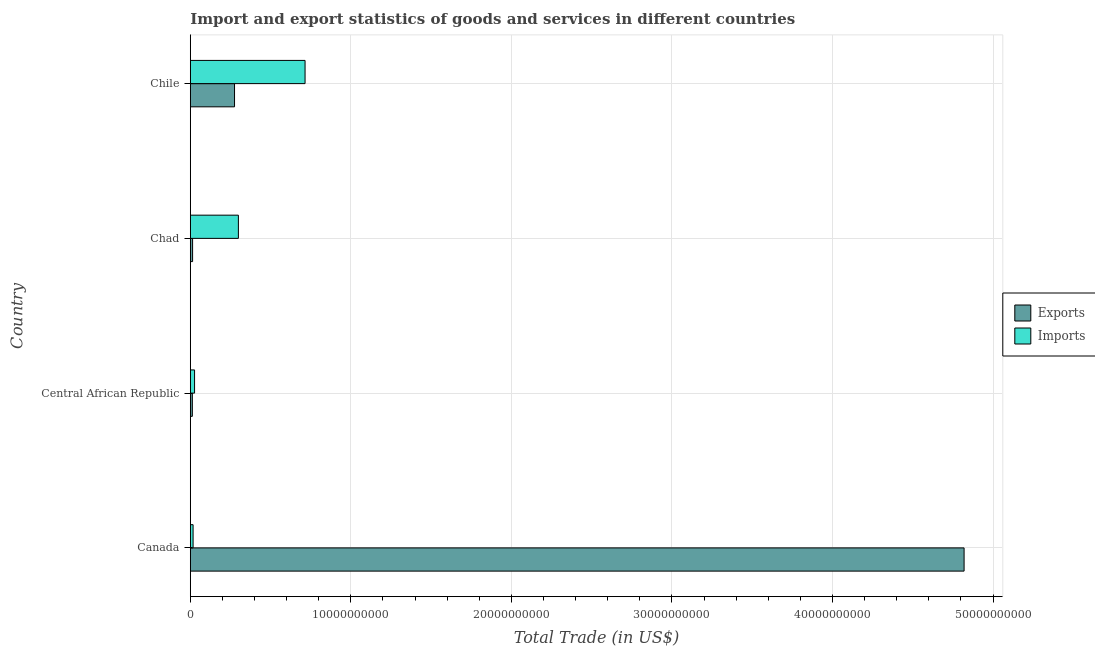How many different coloured bars are there?
Keep it short and to the point. 2. How many groups of bars are there?
Your answer should be compact. 4. In how many cases, is the number of bars for a given country not equal to the number of legend labels?
Your answer should be very brief. 0. What is the imports of goods and services in Chad?
Keep it short and to the point. 3.00e+09. Across all countries, what is the maximum imports of goods and services?
Offer a very short reply. 7.15e+09. Across all countries, what is the minimum imports of goods and services?
Make the answer very short. 1.74e+08. In which country was the imports of goods and services maximum?
Keep it short and to the point. Chile. In which country was the imports of goods and services minimum?
Offer a very short reply. Canada. What is the total export of goods and services in the graph?
Make the answer very short. 5.12e+1. What is the difference between the export of goods and services in Canada and that in Chile?
Provide a succinct answer. 4.54e+1. What is the difference between the export of goods and services in Canada and the imports of goods and services in Chile?
Give a very brief answer. 4.10e+1. What is the average imports of goods and services per country?
Provide a succinct answer. 2.65e+09. What is the difference between the imports of goods and services and export of goods and services in Canada?
Your response must be concise. -4.80e+1. In how many countries, is the imports of goods and services greater than 42000000000 US$?
Provide a short and direct response. 0. What is the ratio of the imports of goods and services in Canada to that in Chad?
Offer a very short reply. 0.06. Is the export of goods and services in Canada less than that in Chad?
Keep it short and to the point. No. Is the difference between the export of goods and services in Canada and Chile greater than the difference between the imports of goods and services in Canada and Chile?
Your response must be concise. Yes. What is the difference between the highest and the second highest export of goods and services?
Keep it short and to the point. 4.54e+1. What is the difference between the highest and the lowest imports of goods and services?
Offer a very short reply. 6.97e+09. Is the sum of the export of goods and services in Central African Republic and Chad greater than the maximum imports of goods and services across all countries?
Your answer should be compact. No. What does the 1st bar from the top in Canada represents?
Ensure brevity in your answer.  Imports. What does the 2nd bar from the bottom in Canada represents?
Offer a terse response. Imports. How many bars are there?
Your response must be concise. 8. How many legend labels are there?
Offer a very short reply. 2. How are the legend labels stacked?
Your answer should be compact. Vertical. What is the title of the graph?
Your answer should be very brief. Import and export statistics of goods and services in different countries. What is the label or title of the X-axis?
Make the answer very short. Total Trade (in US$). What is the Total Trade (in US$) of Exports in Canada?
Keep it short and to the point. 4.82e+1. What is the Total Trade (in US$) in Imports in Canada?
Make the answer very short. 1.74e+08. What is the Total Trade (in US$) in Exports in Central African Republic?
Keep it short and to the point. 1.28e+08. What is the Total Trade (in US$) in Imports in Central African Republic?
Ensure brevity in your answer.  2.65e+08. What is the Total Trade (in US$) of Exports in Chad?
Your answer should be compact. 1.44e+08. What is the Total Trade (in US$) of Imports in Chad?
Provide a succinct answer. 3.00e+09. What is the Total Trade (in US$) in Exports in Chile?
Provide a short and direct response. 2.75e+09. What is the Total Trade (in US$) in Imports in Chile?
Offer a terse response. 7.15e+09. Across all countries, what is the maximum Total Trade (in US$) in Exports?
Your response must be concise. 4.82e+1. Across all countries, what is the maximum Total Trade (in US$) of Imports?
Give a very brief answer. 7.15e+09. Across all countries, what is the minimum Total Trade (in US$) in Exports?
Provide a succinct answer. 1.28e+08. Across all countries, what is the minimum Total Trade (in US$) of Imports?
Offer a terse response. 1.74e+08. What is the total Total Trade (in US$) of Exports in the graph?
Make the answer very short. 5.12e+1. What is the total Total Trade (in US$) of Imports in the graph?
Provide a short and direct response. 1.06e+1. What is the difference between the Total Trade (in US$) in Exports in Canada and that in Central African Republic?
Give a very brief answer. 4.81e+1. What is the difference between the Total Trade (in US$) in Imports in Canada and that in Central African Republic?
Your answer should be compact. -9.13e+07. What is the difference between the Total Trade (in US$) in Exports in Canada and that in Chad?
Offer a very short reply. 4.81e+1. What is the difference between the Total Trade (in US$) in Imports in Canada and that in Chad?
Your answer should be very brief. -2.82e+09. What is the difference between the Total Trade (in US$) in Exports in Canada and that in Chile?
Provide a short and direct response. 4.54e+1. What is the difference between the Total Trade (in US$) of Imports in Canada and that in Chile?
Give a very brief answer. -6.97e+09. What is the difference between the Total Trade (in US$) of Exports in Central African Republic and that in Chad?
Offer a very short reply. -1.58e+07. What is the difference between the Total Trade (in US$) of Imports in Central African Republic and that in Chad?
Offer a very short reply. -2.73e+09. What is the difference between the Total Trade (in US$) in Exports in Central African Republic and that in Chile?
Your answer should be compact. -2.63e+09. What is the difference between the Total Trade (in US$) of Imports in Central African Republic and that in Chile?
Offer a terse response. -6.88e+09. What is the difference between the Total Trade (in US$) of Exports in Chad and that in Chile?
Keep it short and to the point. -2.61e+09. What is the difference between the Total Trade (in US$) in Imports in Chad and that in Chile?
Offer a terse response. -4.15e+09. What is the difference between the Total Trade (in US$) in Exports in Canada and the Total Trade (in US$) in Imports in Central African Republic?
Provide a succinct answer. 4.79e+1. What is the difference between the Total Trade (in US$) of Exports in Canada and the Total Trade (in US$) of Imports in Chad?
Ensure brevity in your answer.  4.52e+1. What is the difference between the Total Trade (in US$) of Exports in Canada and the Total Trade (in US$) of Imports in Chile?
Provide a short and direct response. 4.10e+1. What is the difference between the Total Trade (in US$) of Exports in Central African Republic and the Total Trade (in US$) of Imports in Chad?
Keep it short and to the point. -2.87e+09. What is the difference between the Total Trade (in US$) in Exports in Central African Republic and the Total Trade (in US$) in Imports in Chile?
Your response must be concise. -7.02e+09. What is the difference between the Total Trade (in US$) in Exports in Chad and the Total Trade (in US$) in Imports in Chile?
Ensure brevity in your answer.  -7.00e+09. What is the average Total Trade (in US$) of Exports per country?
Offer a terse response. 1.28e+1. What is the average Total Trade (in US$) in Imports per country?
Your answer should be compact. 2.65e+09. What is the difference between the Total Trade (in US$) in Exports and Total Trade (in US$) in Imports in Canada?
Provide a short and direct response. 4.80e+1. What is the difference between the Total Trade (in US$) of Exports and Total Trade (in US$) of Imports in Central African Republic?
Your response must be concise. -1.38e+08. What is the difference between the Total Trade (in US$) in Exports and Total Trade (in US$) in Imports in Chad?
Give a very brief answer. -2.85e+09. What is the difference between the Total Trade (in US$) in Exports and Total Trade (in US$) in Imports in Chile?
Make the answer very short. -4.39e+09. What is the ratio of the Total Trade (in US$) in Exports in Canada to that in Central African Republic?
Give a very brief answer. 376.92. What is the ratio of the Total Trade (in US$) of Imports in Canada to that in Central African Republic?
Keep it short and to the point. 0.66. What is the ratio of the Total Trade (in US$) in Exports in Canada to that in Chad?
Give a very brief answer. 335.58. What is the ratio of the Total Trade (in US$) in Imports in Canada to that in Chad?
Provide a short and direct response. 0.06. What is the ratio of the Total Trade (in US$) of Exports in Canada to that in Chile?
Your answer should be very brief. 17.49. What is the ratio of the Total Trade (in US$) in Imports in Canada to that in Chile?
Keep it short and to the point. 0.02. What is the ratio of the Total Trade (in US$) in Exports in Central African Republic to that in Chad?
Your answer should be compact. 0.89. What is the ratio of the Total Trade (in US$) in Imports in Central African Republic to that in Chad?
Provide a succinct answer. 0.09. What is the ratio of the Total Trade (in US$) in Exports in Central African Republic to that in Chile?
Your answer should be compact. 0.05. What is the ratio of the Total Trade (in US$) in Imports in Central African Republic to that in Chile?
Your answer should be compact. 0.04. What is the ratio of the Total Trade (in US$) of Exports in Chad to that in Chile?
Offer a terse response. 0.05. What is the ratio of the Total Trade (in US$) in Imports in Chad to that in Chile?
Offer a terse response. 0.42. What is the difference between the highest and the second highest Total Trade (in US$) of Exports?
Keep it short and to the point. 4.54e+1. What is the difference between the highest and the second highest Total Trade (in US$) in Imports?
Your answer should be compact. 4.15e+09. What is the difference between the highest and the lowest Total Trade (in US$) in Exports?
Provide a short and direct response. 4.81e+1. What is the difference between the highest and the lowest Total Trade (in US$) of Imports?
Your answer should be compact. 6.97e+09. 